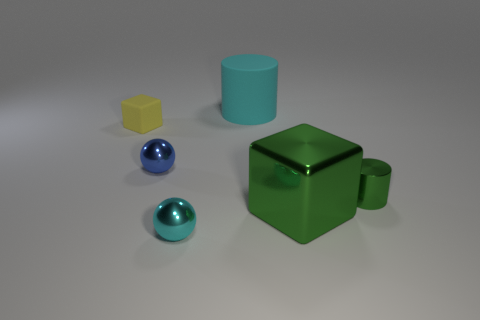Add 4 green metal objects. How many objects exist? 10 Subtract all cylinders. How many objects are left? 4 Add 2 big brown cubes. How many big brown cubes exist? 2 Subtract 0 purple cylinders. How many objects are left? 6 Subtract all tiny blue rubber things. Subtract all rubber objects. How many objects are left? 4 Add 6 green shiny objects. How many green shiny objects are left? 8 